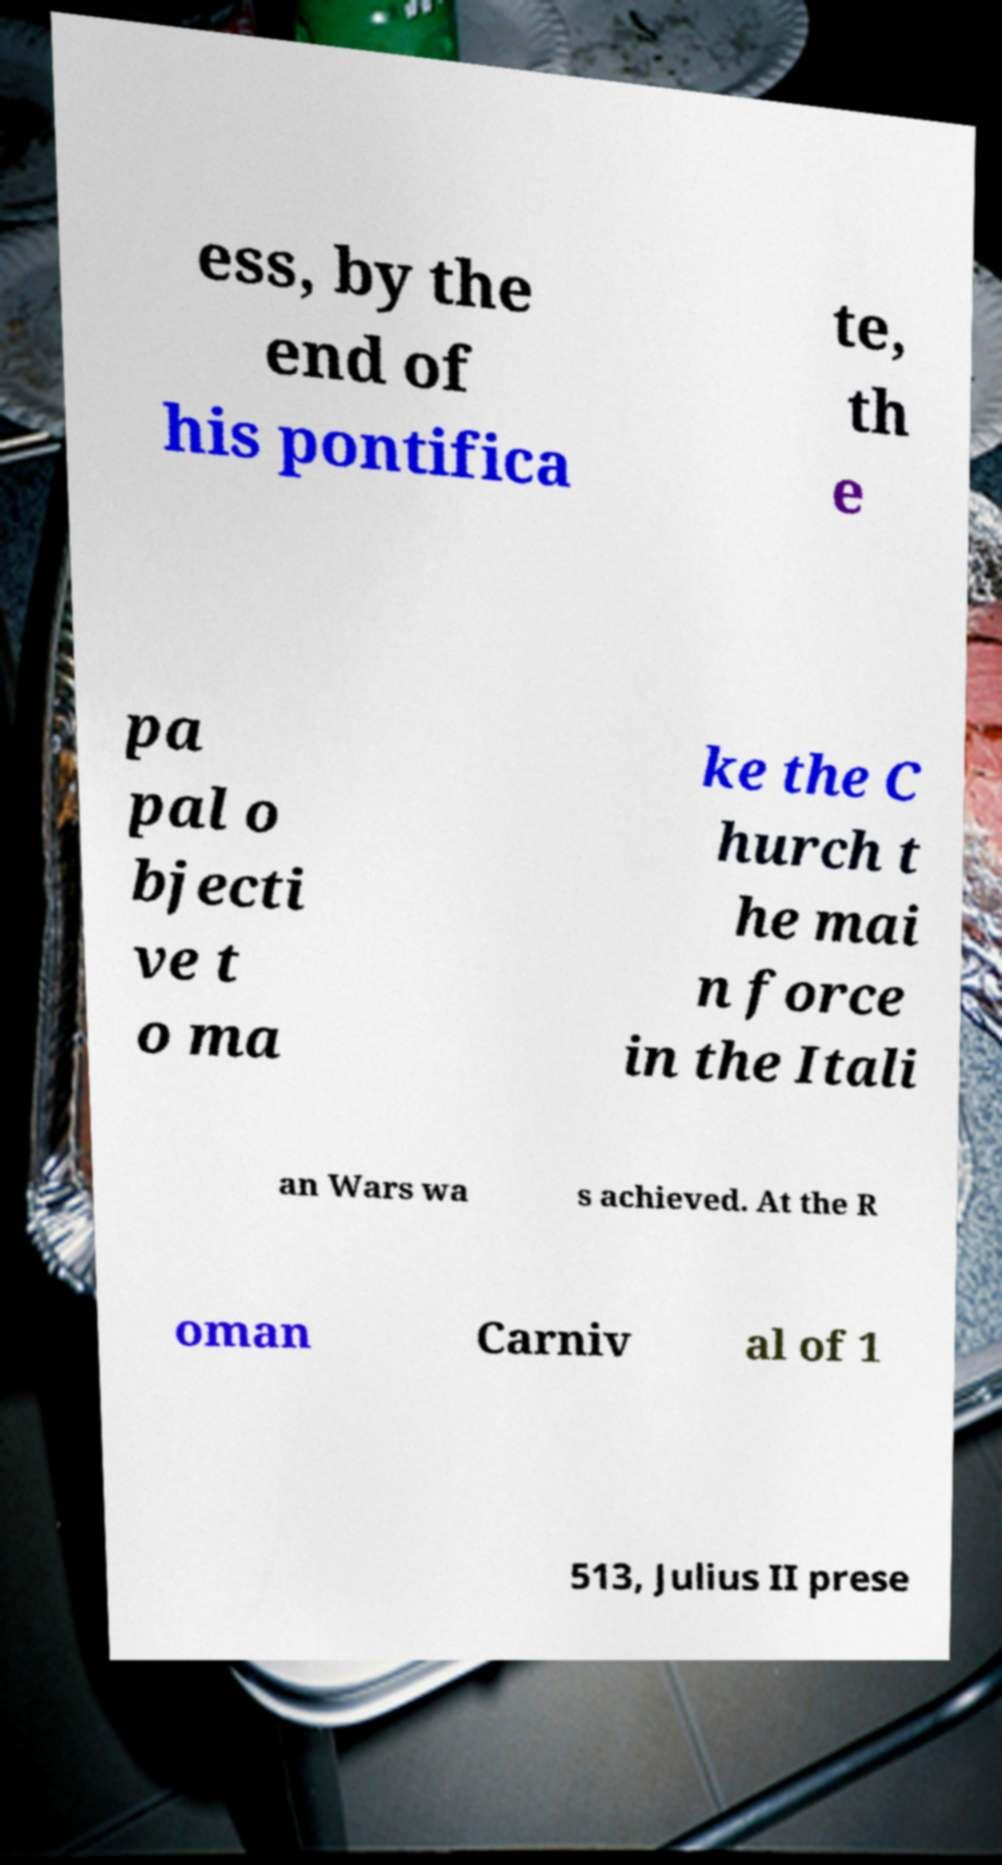Please read and relay the text visible in this image. What does it say? ess, by the end of his pontifica te, th e pa pal o bjecti ve t o ma ke the C hurch t he mai n force in the Itali an Wars wa s achieved. At the R oman Carniv al of 1 513, Julius II prese 